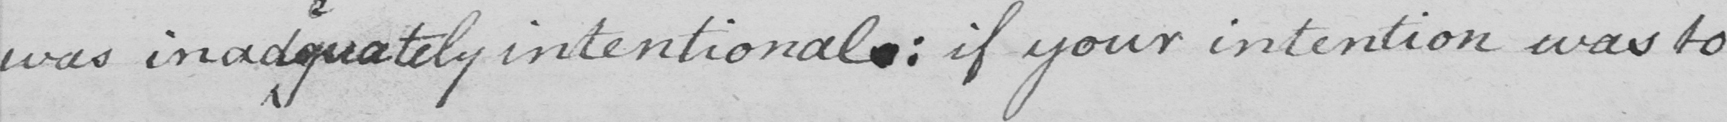Please transcribe the handwritten text in this image. was inad quately intentional: if your intention was to 